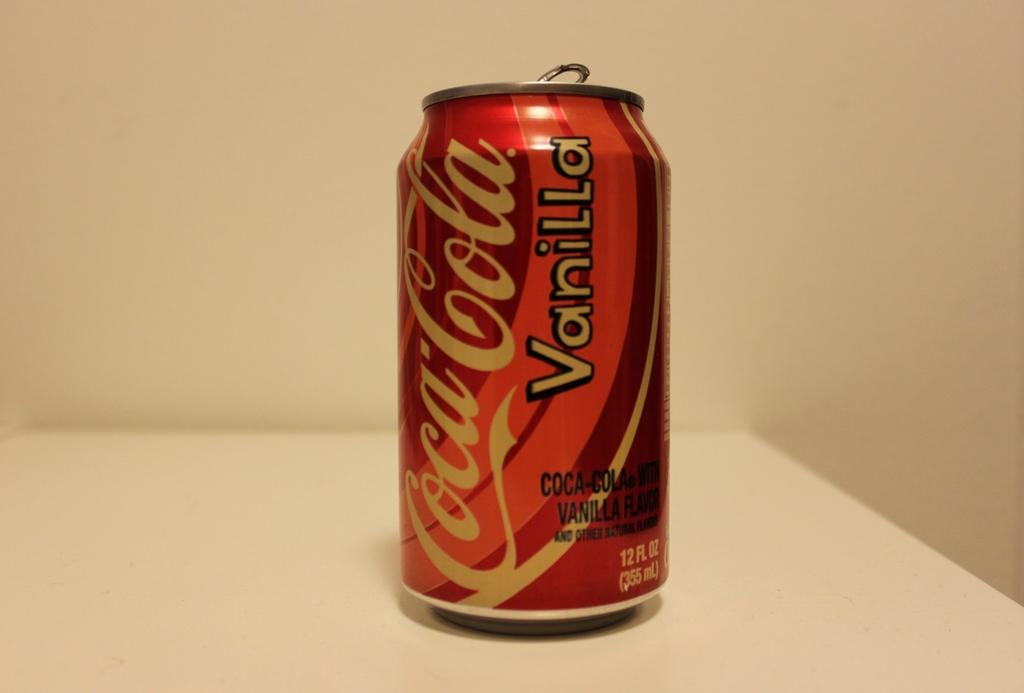<image>
Create a compact narrative representing the image presented. An opened can of vanilla flavored Coca Cola. 